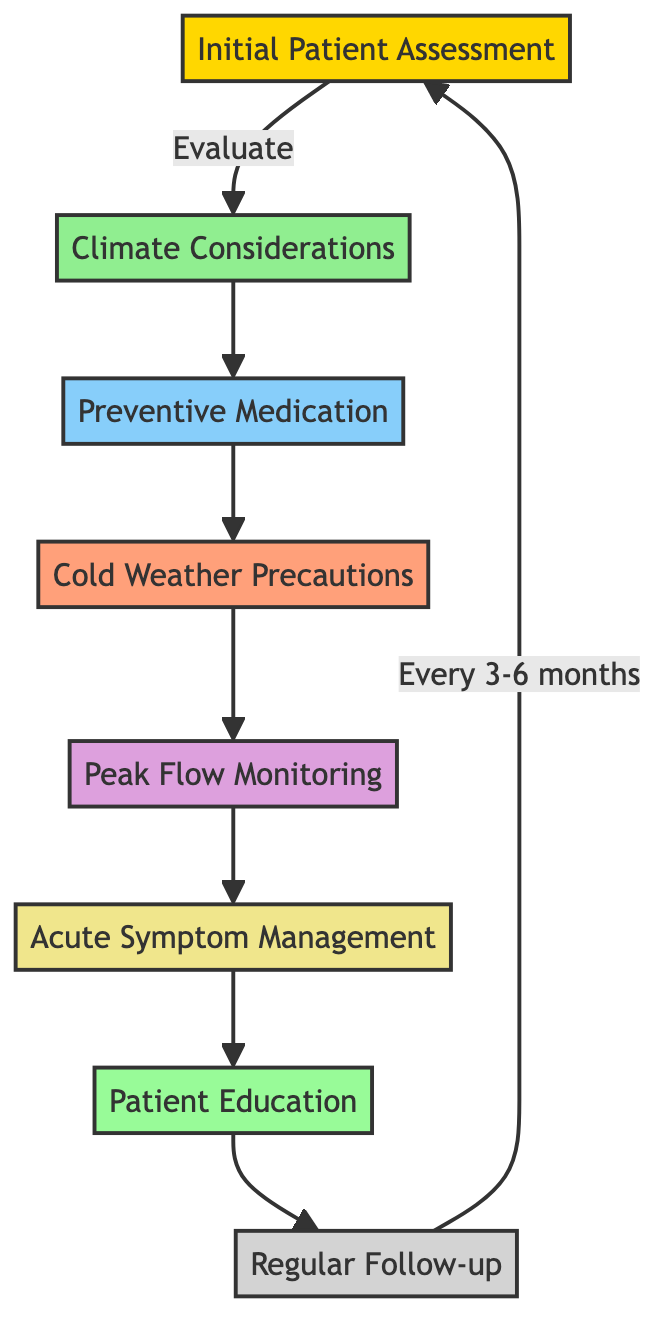What is the first step in the asthma management pathway? The first step in the pathway is the "Initial Patient Assessment," where the patient's asthma severity, triggers, and history are evaluated.
Answer: Initial Patient Assessment How many medication types are listed in the pathway? The pathway lists two types of medications: "Preventive Medication" and "Acute Symptom Management."
Answer: 2 What precaution is recommended for cold weather? The pathway advises wearing a scarf over the nose and mouth to mitigate cold effects.
Answer: Wear a scarf over nose and mouth What is the purpose of Peak Flow Monitoring? Peak Flow Monitoring is used for detecting early asthma exacerbations through daily monitoring with a peak flow meter.
Answer: Detect early asthma exacerbations What action follows Patient Education? Following Patient Education, the next action is "Regular Follow-up" to ensure ongoing care and monitoring.
Answer: Regular Follow-up Which medication is used for acute symptom management? The medication indicated for acute symptom management is a short-acting beta agonist like Albuterol.
Answer: Albuterol What should patients do every 3-6 months? Patients are advised to have "Regular Follow-up" visits with a healthcare provider every 3-6 months.
Answer: Regular Follow-up What is the relationship between Climate Considerations and Preventive Medication? Climate Considerations lead to the consideration of Preventive Medication to address asthma management in cold weather.
Answer: Climate Considerations lead to Preventive Medication How does the pathway cycle back to the beginning? The pathway cycles back to the "Initial Patient Assessment" after the "Regular Follow-up," creating a continuous loop for ongoing management.
Answer: Continuous loop back to Initial Patient Assessment 